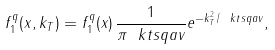<formula> <loc_0><loc_0><loc_500><loc_500>f _ { 1 } ^ { q } ( x , k _ { T } ) = f _ { 1 } ^ { q } ( x ) \, \frac { 1 } { \pi \ k t s q a v } e ^ { - k _ { T } ^ { 2 } / \ k t s q a v } ,</formula> 